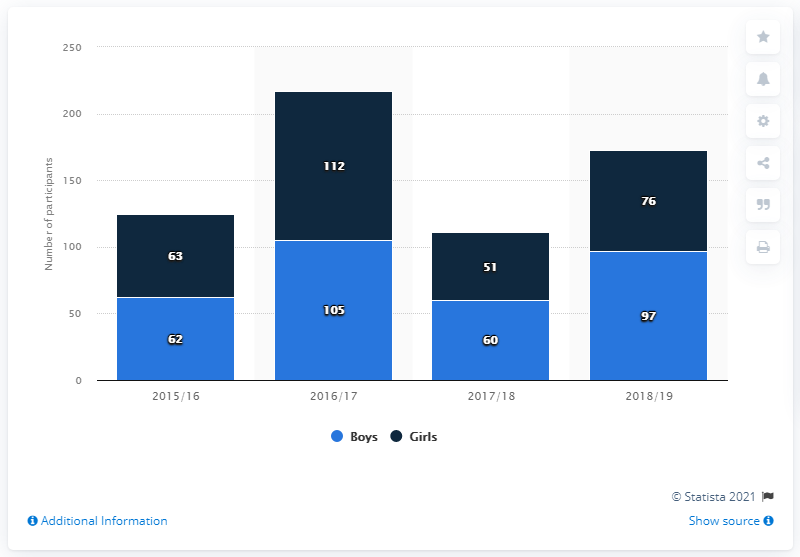Specify some key components in this picture. In the 2018/19 school year, 97 male students participated in the high school rock climbing program. 